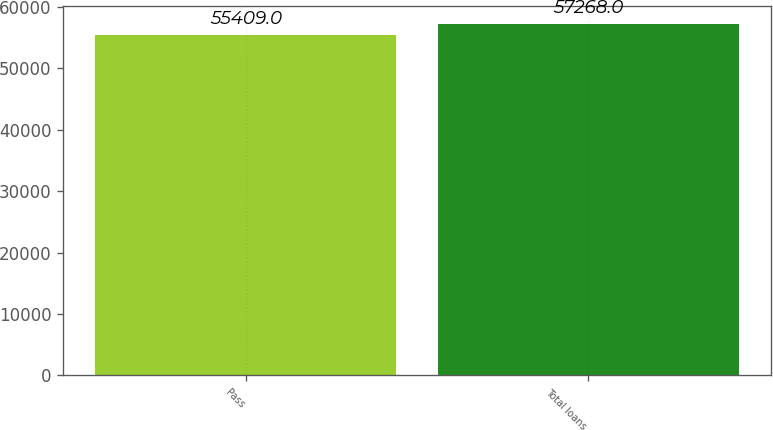Convert chart. <chart><loc_0><loc_0><loc_500><loc_500><bar_chart><fcel>Pass<fcel>Total loans<nl><fcel>55409<fcel>57268<nl></chart> 